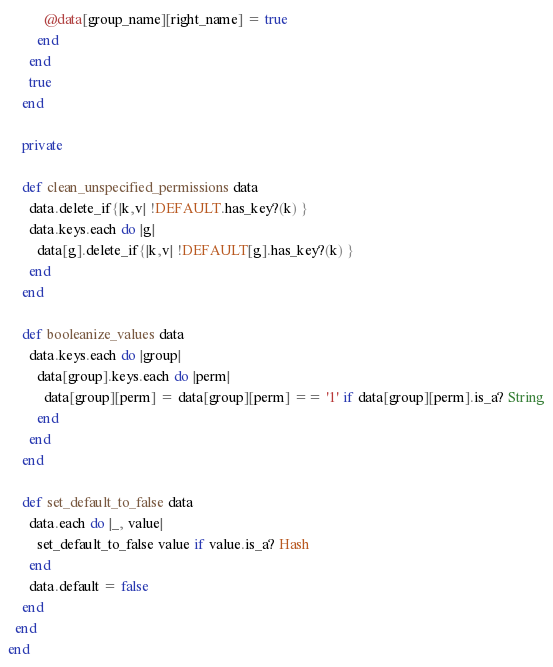<code> <loc_0><loc_0><loc_500><loc_500><_Ruby_>          @data[group_name][right_name] = true
        end
      end
      true
    end

    private

    def clean_unspecified_permissions data
      data.delete_if{|k,v| !DEFAULT.has_key?(k) }
      data.keys.each do |g|
        data[g].delete_if{|k,v| !DEFAULT[g].has_key?(k) }
      end
    end

    def booleanize_values data
      data.keys.each do |group|
        data[group].keys.each do |perm|
          data[group][perm] = data[group][perm] == '1' if data[group][perm].is_a? String
        end
      end
    end

    def set_default_to_false data
      data.each do |_, value|
        set_default_to_false value if value.is_a? Hash
      end
      data.default = false
    end
  end
end</code> 